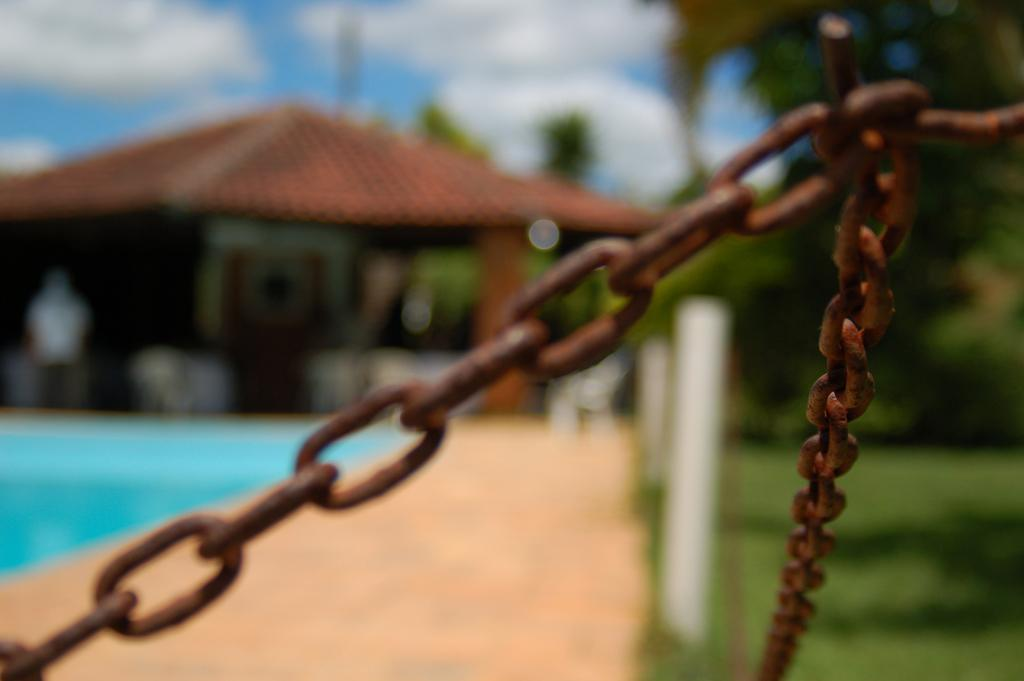What objects can be seen in the image related to lifting or securing? There are chains and a hook in the image. How would you describe the background of the image? The background has a blurred view. What type of structure is visible in the image? There is a shed in the image. Can you describe any path or walkway in the image? There is a walkway in the image. What type of natural elements are present in the image? Trees are present in the image. What part of the natural environment is visible in the image? The sky is visible in the image. What type of belief is being discussed in the lunchroom in the image? There is no lunchroom or discussion of beliefs present in the image. 